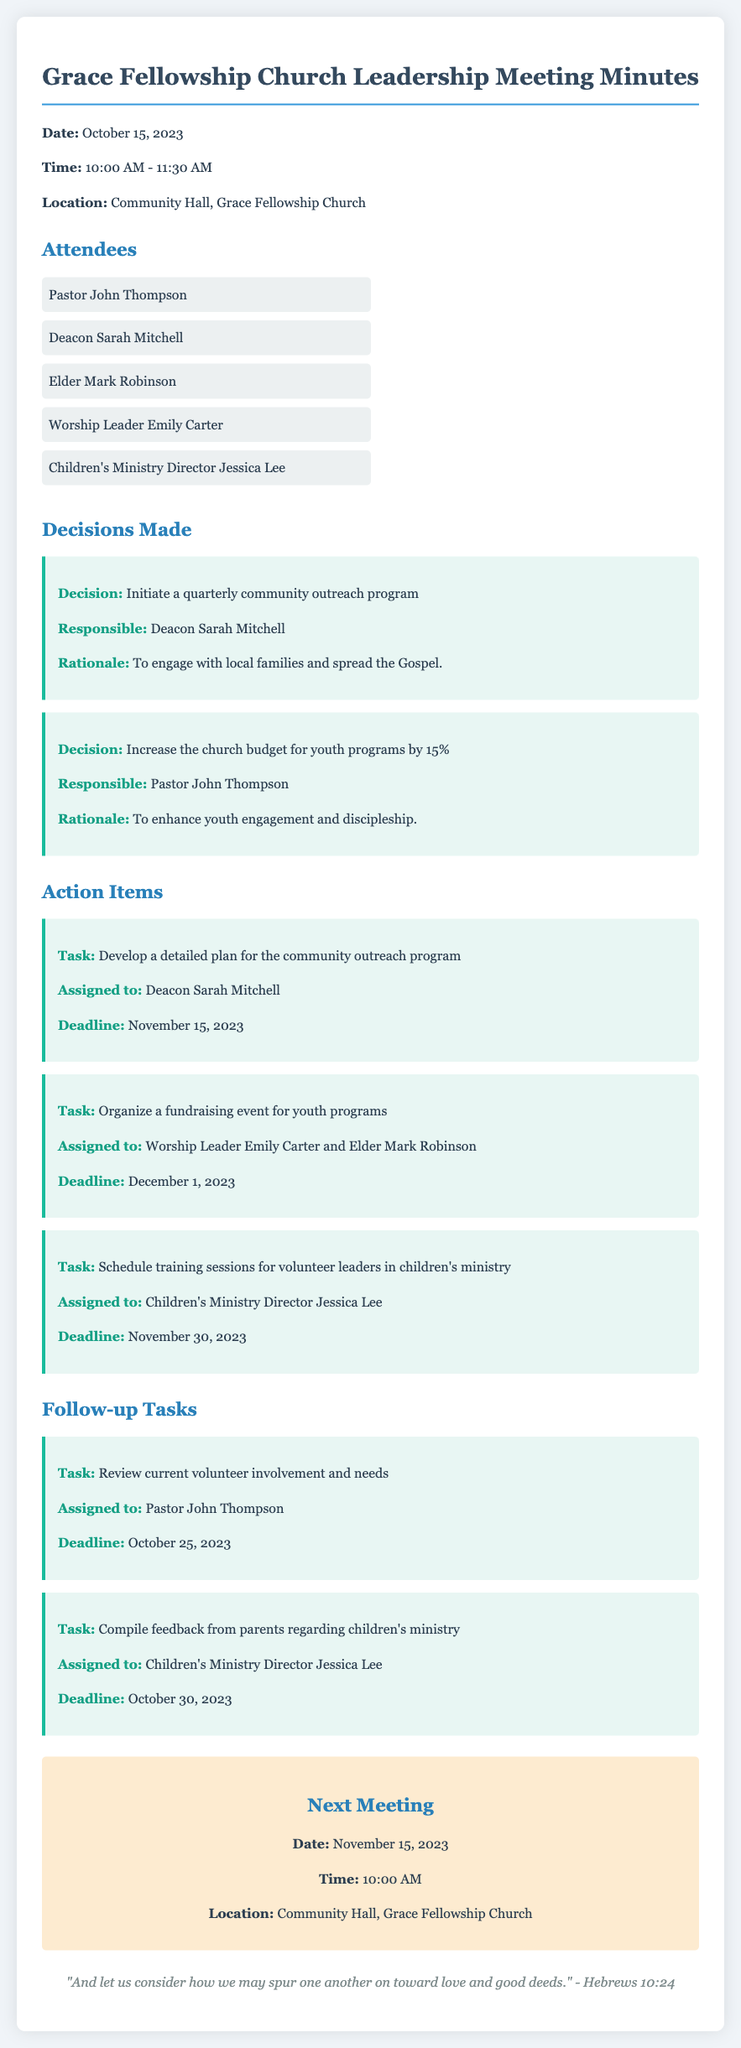What is the date of the meeting? The date of the meeting is mentioned at the beginning of the document as October 15, 2023.
Answer: October 15, 2023 Who is responsible for the community outreach program? The individual responsible for the community outreach program is identified in the decisions made section as Deacon Sarah Mitchell.
Answer: Deacon Sarah Mitchell What is the deadline for developing the outreach program plan? The deadline for the outreach program plan is specified in the action items section as November 15, 2023.
Answer: November 15, 2023 What decision involves the church budget? The decision about the church budget is to increase the budget for youth programs by 15%.
Answer: Increase the church budget for youth programs by 15% Which ministries require feedback compilation? The document states that feedback needs to be compiled from parents regarding children's ministry.
Answer: Children's ministry When is the next meeting scheduled? The date for the next meeting is provided in the document as November 15, 2023.
Answer: November 15, 2023 How long did the meeting last? The meeting started at 10:00 AM and ended at 11:30 AM, indicating a duration of 1 hour and 30 minutes.
Answer: 1 hour and 30 minutes What task is assigned to Pastor John Thompson? The task assigned to Pastor John Thompson is to review current volunteer involvement and needs.
Answer: Review current volunteer involvement and needs 